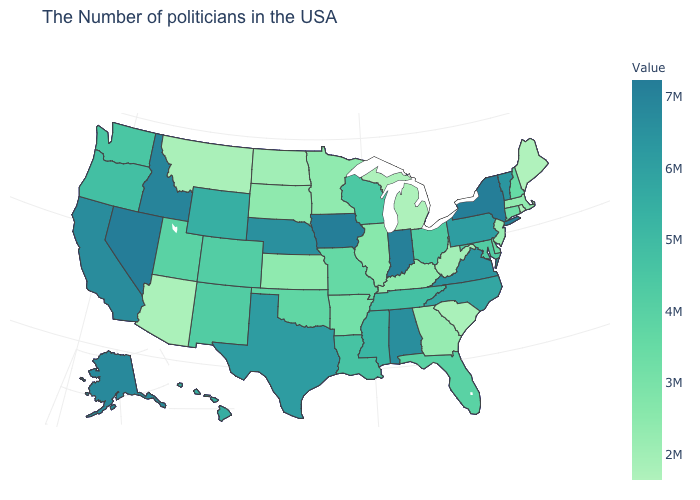Does Pennsylvania have a lower value than Alaska?
Answer briefly. Yes. Is the legend a continuous bar?
Keep it brief. Yes. Which states have the lowest value in the Northeast?
Write a very short answer. Rhode Island. Does Iowa have a higher value than North Dakota?
Write a very short answer. Yes. Among the states that border Connecticut , does Rhode Island have the lowest value?
Quick response, please. Yes. Among the states that border Oklahoma , which have the highest value?
Keep it brief. Texas. Does Alabama have a lower value than Nevada?
Keep it brief. Yes. Does New York have the highest value in the Northeast?
Quick response, please. Yes. Which states hav the highest value in the MidWest?
Write a very short answer. Iowa. 